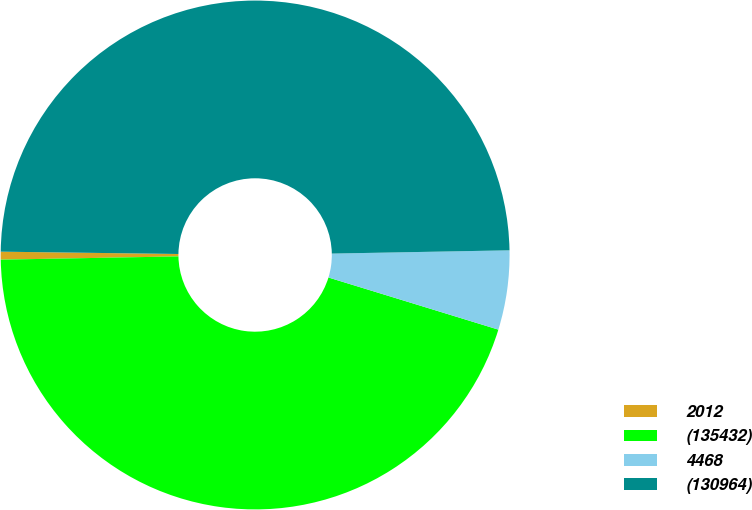<chart> <loc_0><loc_0><loc_500><loc_500><pie_chart><fcel>2012<fcel>(135432)<fcel>4468<fcel>(130964)<nl><fcel>0.5%<fcel>44.97%<fcel>5.03%<fcel>49.5%<nl></chart> 